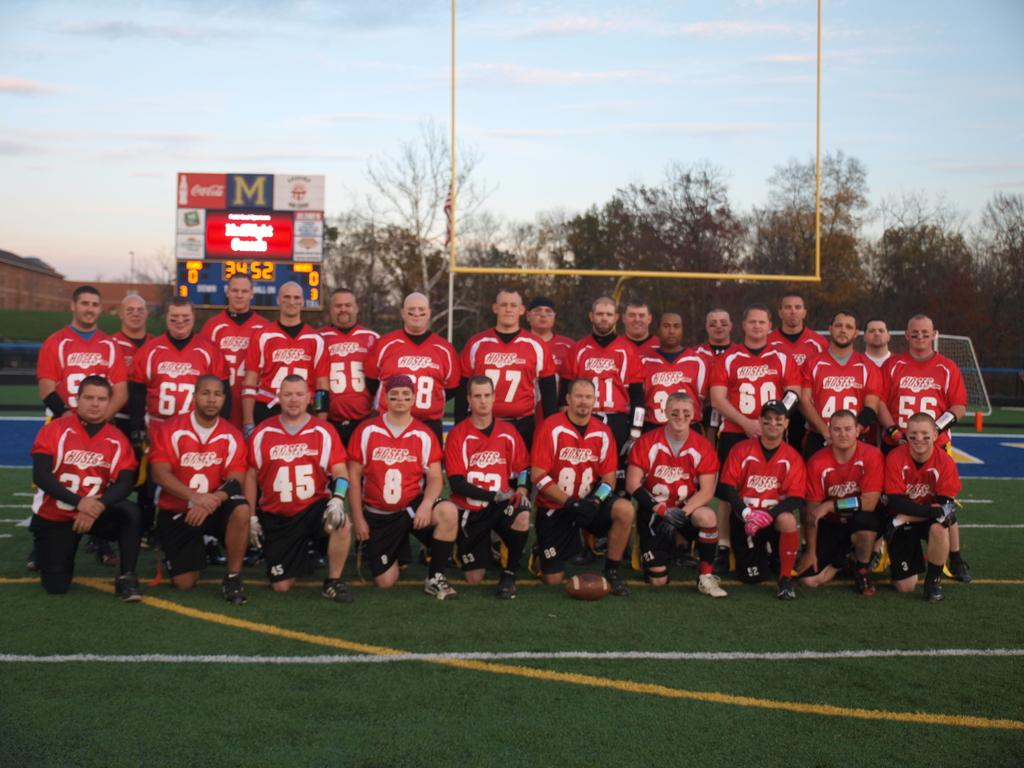Provide a one-sentence caption for the provided image. The Hoses football team takes a team picture in front of the Score board on the field. 